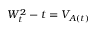Convert formula to latex. <formula><loc_0><loc_0><loc_500><loc_500>W _ { t } ^ { 2 } - t = V _ { A ( t ) }</formula> 